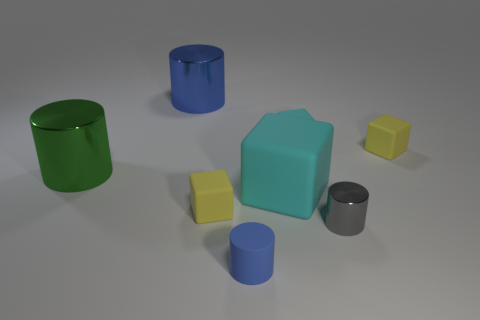What number of small yellow rubber objects are there?
Provide a succinct answer. 2. Are the large cyan cube and the yellow block that is to the left of the large cyan matte cube made of the same material?
Provide a short and direct response. Yes. What is the material of the thing that is the same color as the small matte cylinder?
Your answer should be compact. Metal. How many small cubes have the same color as the big cube?
Make the answer very short. 1. What is the size of the green metal object?
Offer a very short reply. Large. Does the big blue thing have the same shape as the small metal object that is behind the blue rubber object?
Your answer should be very brief. Yes. What is the color of the other tiny cylinder that is the same material as the green cylinder?
Make the answer very short. Gray. What size is the blue object that is behind the large block?
Your response must be concise. Large. Is the number of cyan matte objects to the left of the big blue metal cylinder less than the number of big blue cubes?
Provide a short and direct response. No. Are there fewer small cyan things than metallic cylinders?
Ensure brevity in your answer.  Yes. 